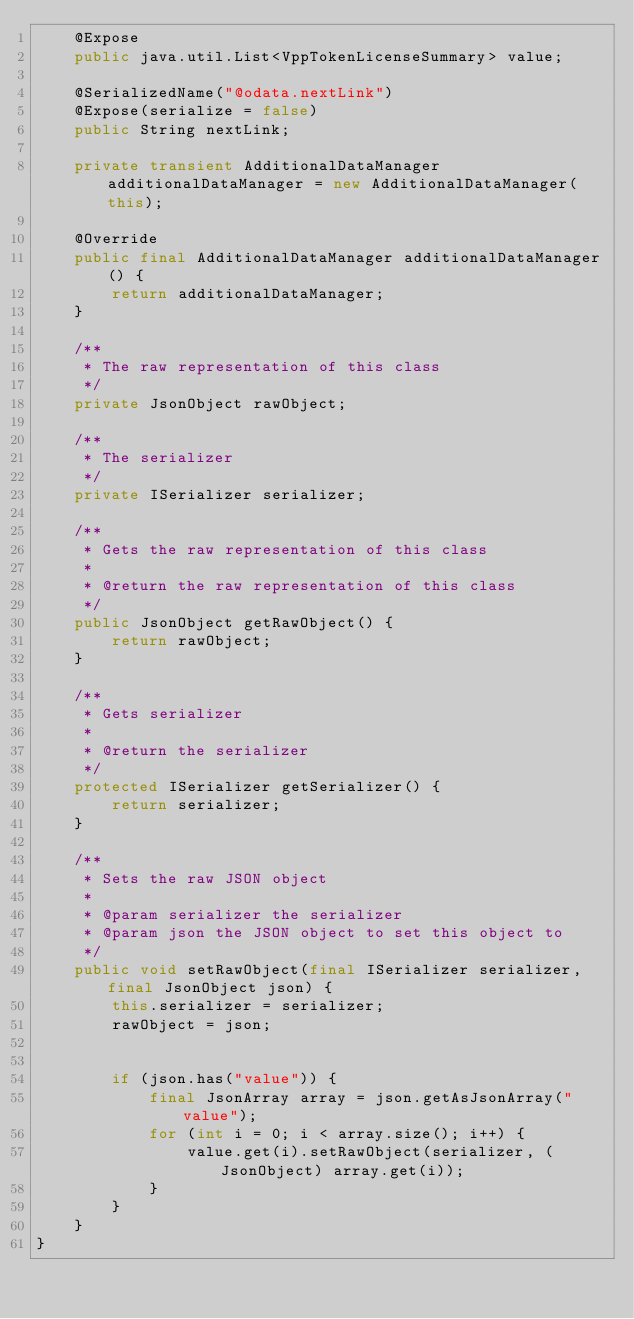<code> <loc_0><loc_0><loc_500><loc_500><_Java_>    @Expose
    public java.util.List<VppTokenLicenseSummary> value;

    @SerializedName("@odata.nextLink")
    @Expose(serialize = false)
    public String nextLink;

    private transient AdditionalDataManager additionalDataManager = new AdditionalDataManager(this);

    @Override
    public final AdditionalDataManager additionalDataManager() {
        return additionalDataManager;
    }

    /**
     * The raw representation of this class
     */
    private JsonObject rawObject;

    /**
     * The serializer
     */
    private ISerializer serializer;

    /**
     * Gets the raw representation of this class
     *
     * @return the raw representation of this class
     */
    public JsonObject getRawObject() {
        return rawObject;
    }

    /**
     * Gets serializer
     *
     * @return the serializer
     */
    protected ISerializer getSerializer() {
        return serializer;
    }

    /**
     * Sets the raw JSON object
     *
     * @param serializer the serializer
     * @param json the JSON object to set this object to
     */
    public void setRawObject(final ISerializer serializer, final JsonObject json) {
        this.serializer = serializer;
        rawObject = json;


        if (json.has("value")) {
            final JsonArray array = json.getAsJsonArray("value");
            for (int i = 0; i < array.size(); i++) {
                value.get(i).setRawObject(serializer, (JsonObject) array.get(i));
            }
        }
    }
}
</code> 